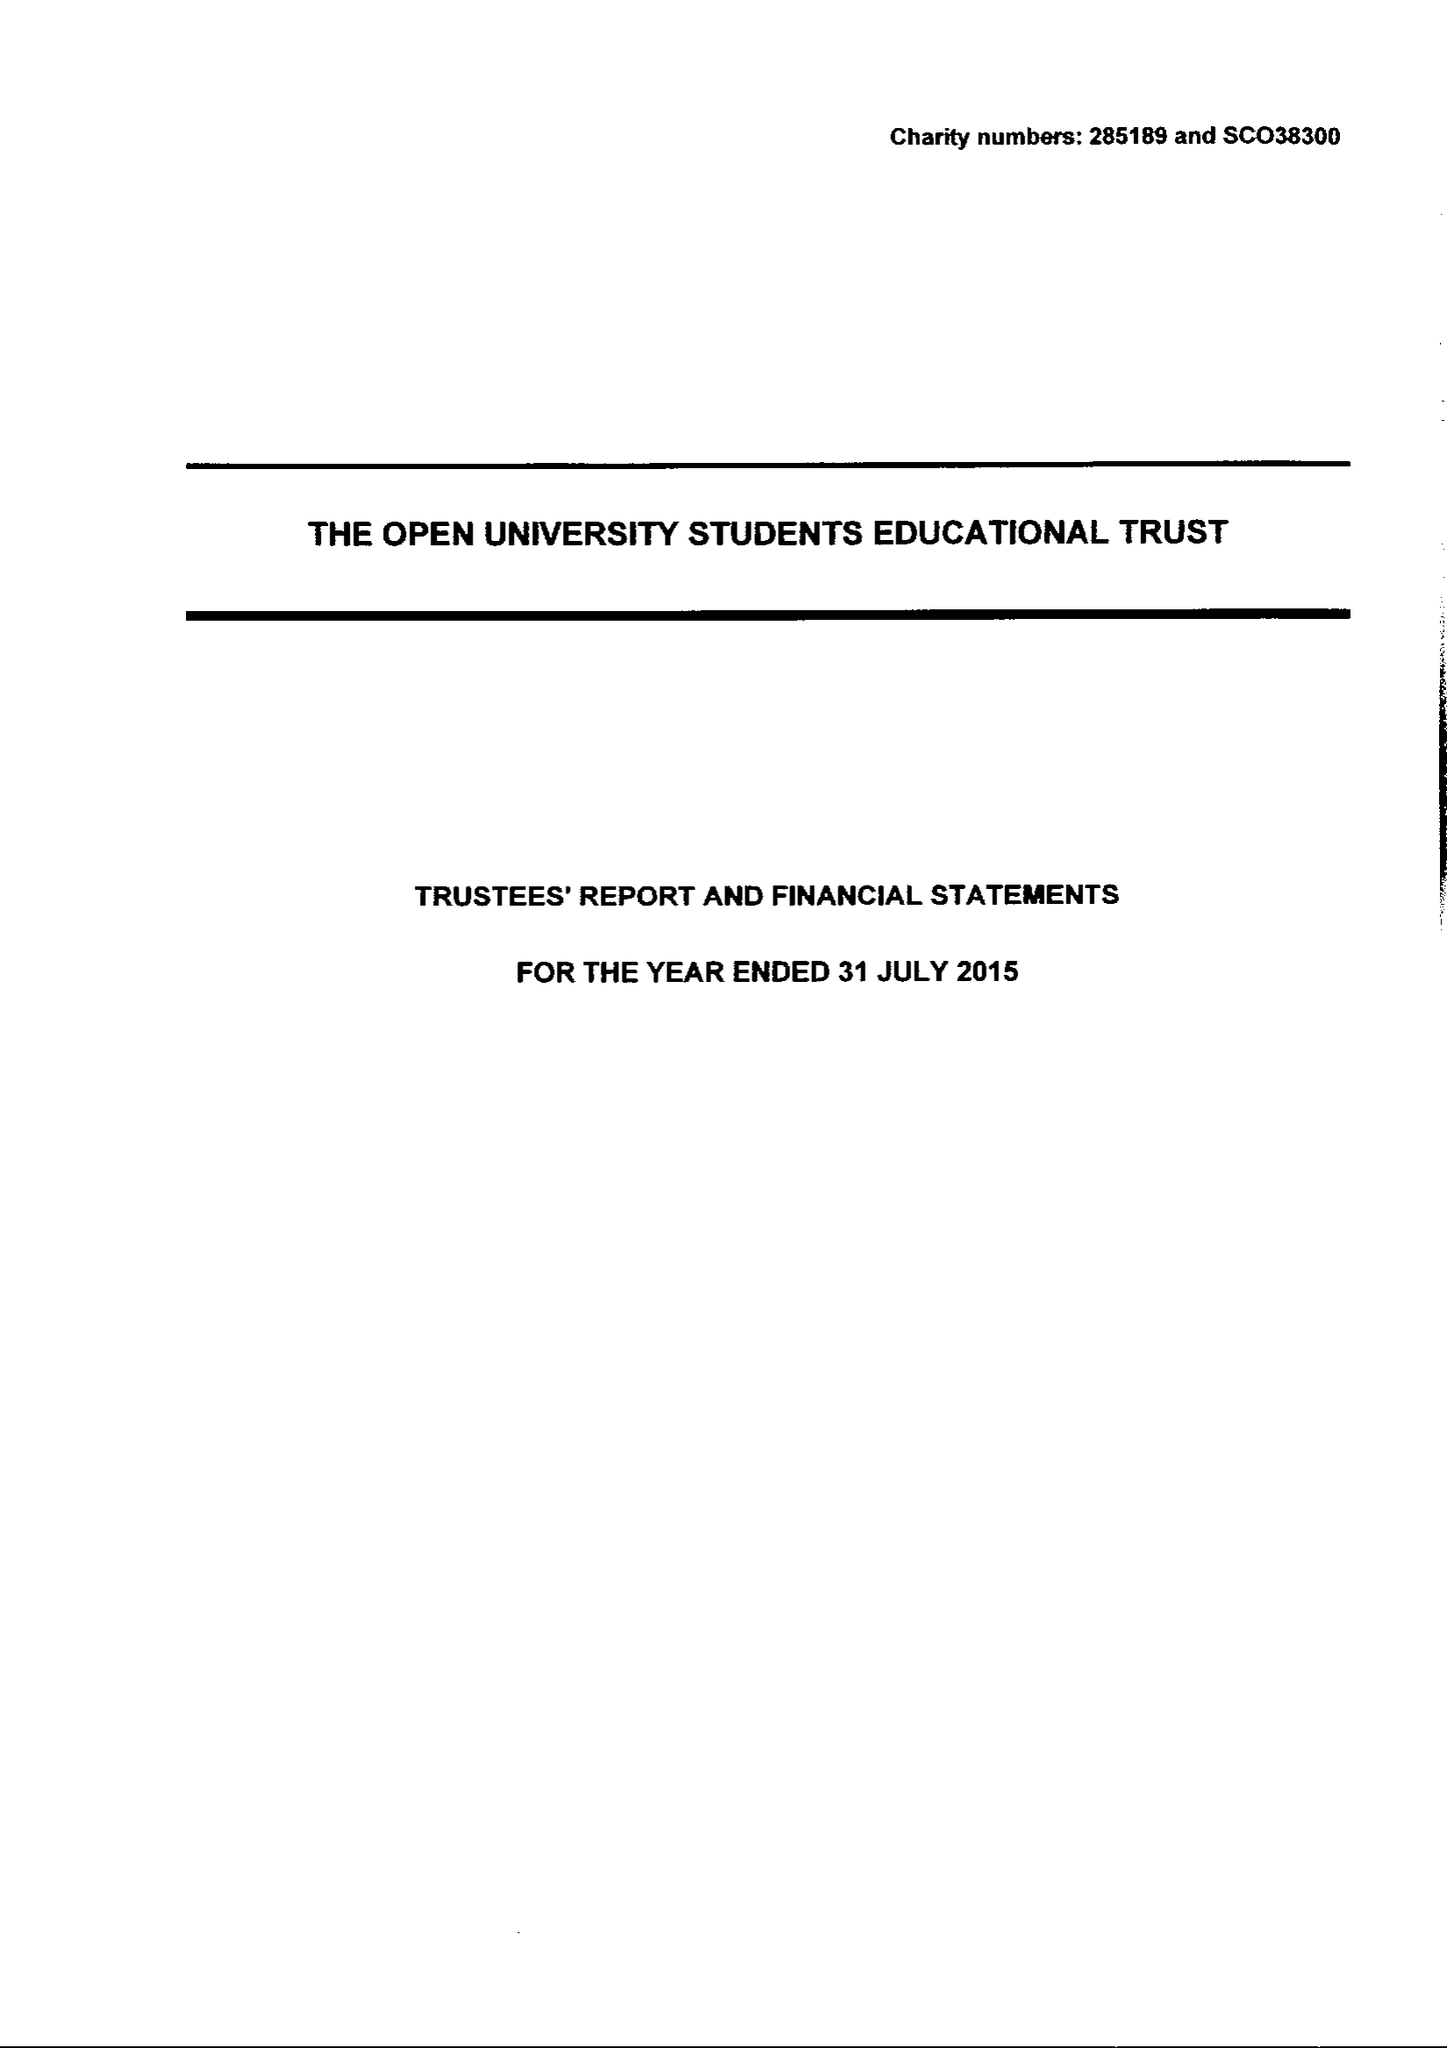What is the value for the charity_name?
Answer the question using a single word or phrase. The Open University Students Educational Trust 